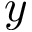<formula> <loc_0><loc_0><loc_500><loc_500>y</formula> 